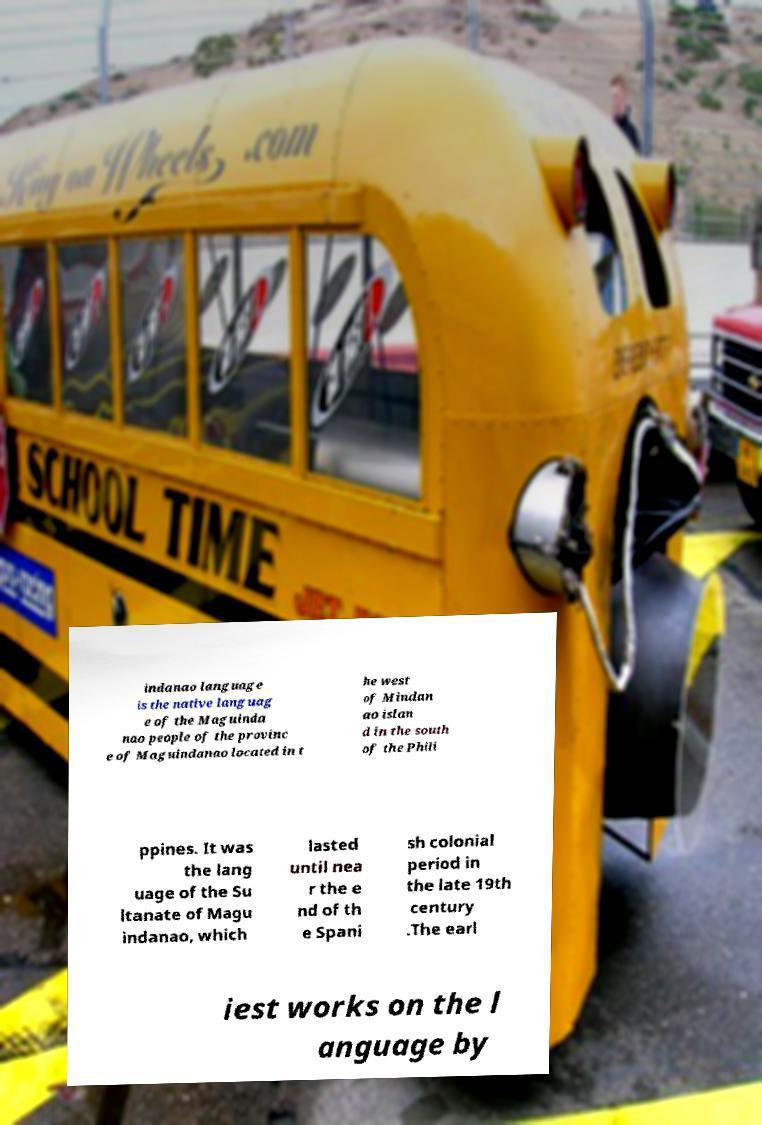Can you accurately transcribe the text from the provided image for me? indanao language is the native languag e of the Maguinda nao people of the provinc e of Maguindanao located in t he west of Mindan ao islan d in the south of the Phili ppines. It was the lang uage of the Su ltanate of Magu indanao, which lasted until nea r the e nd of th e Spani sh colonial period in the late 19th century .The earl iest works on the l anguage by 